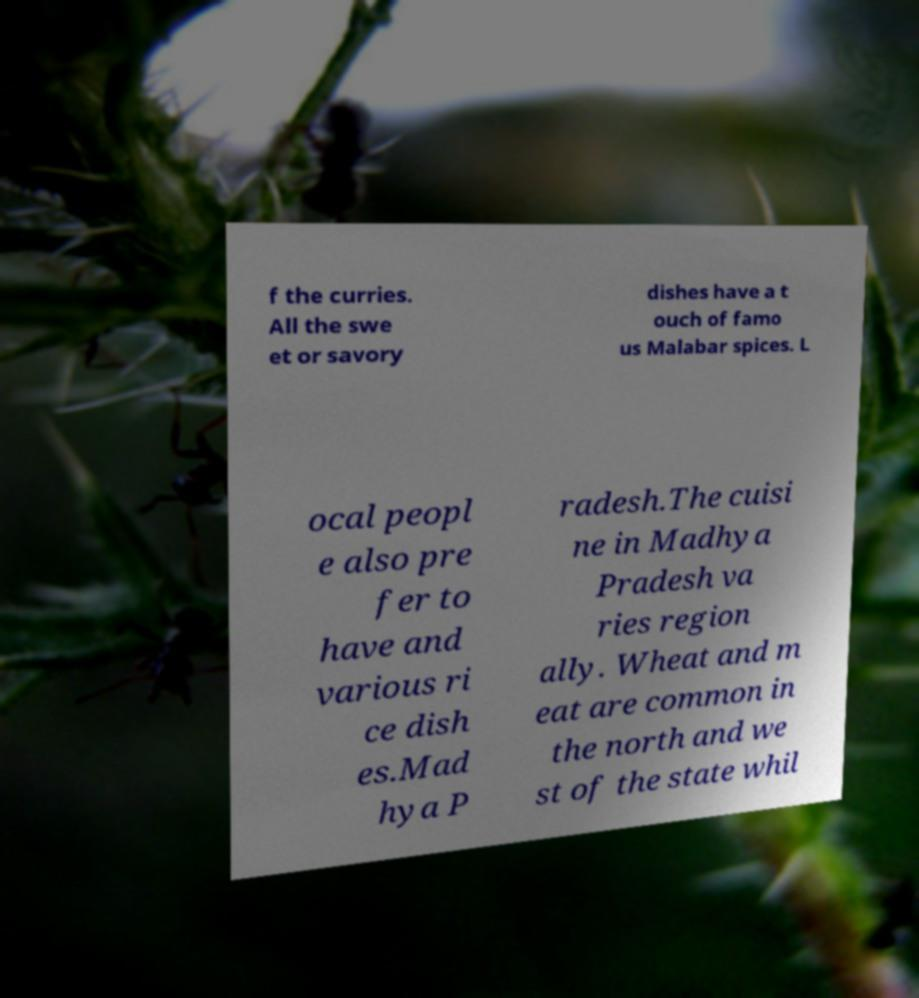There's text embedded in this image that I need extracted. Can you transcribe it verbatim? f the curries. All the swe et or savory dishes have a t ouch of famo us Malabar spices. L ocal peopl e also pre fer to have and various ri ce dish es.Mad hya P radesh.The cuisi ne in Madhya Pradesh va ries region ally. Wheat and m eat are common in the north and we st of the state whil 